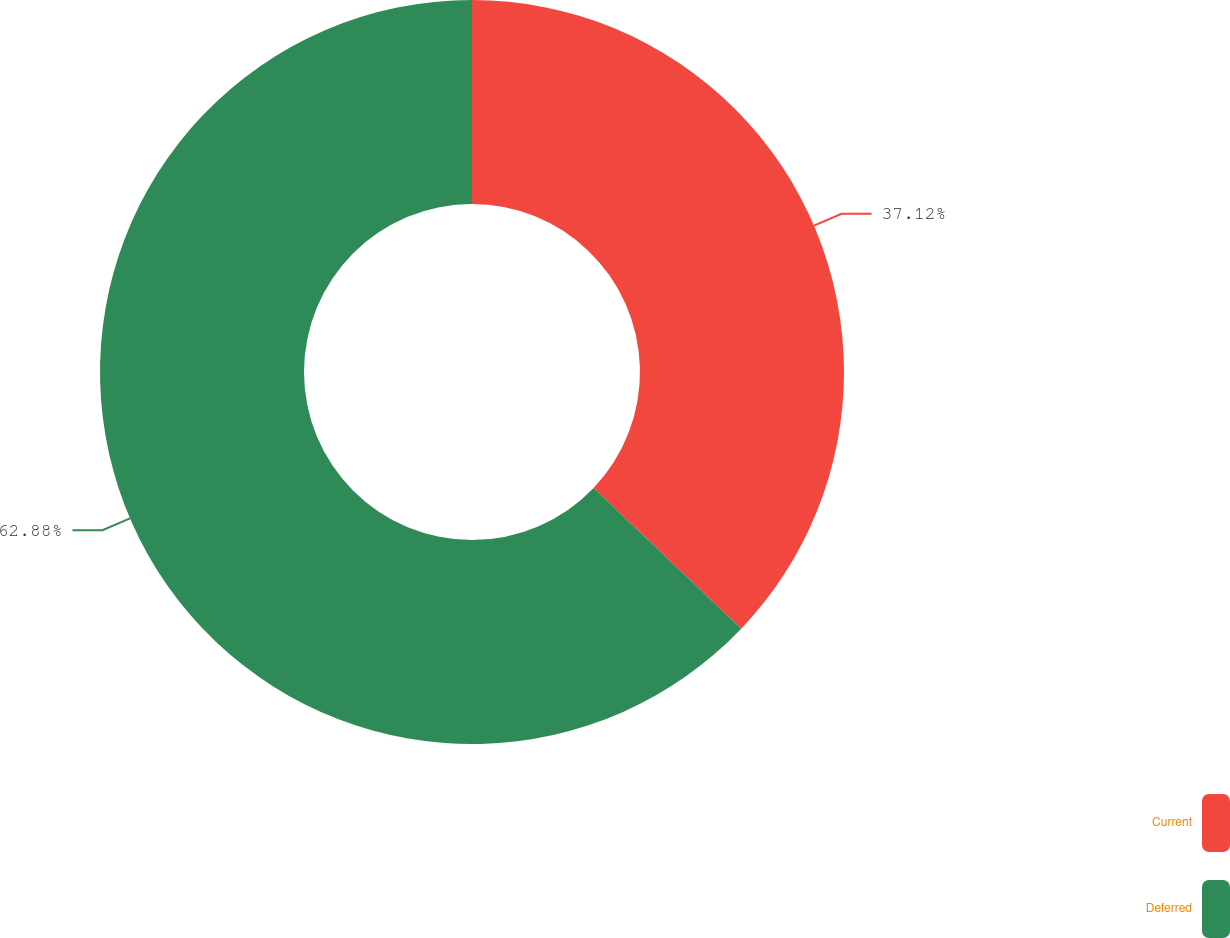Convert chart. <chart><loc_0><loc_0><loc_500><loc_500><pie_chart><fcel>Current<fcel>Deferred<nl><fcel>37.12%<fcel>62.88%<nl></chart> 